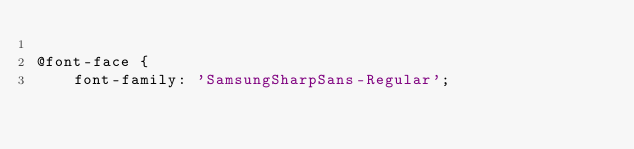<code> <loc_0><loc_0><loc_500><loc_500><_CSS_>
@font-face {
    font-family: 'SamsungSharpSans-Regular';</code> 